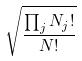<formula> <loc_0><loc_0><loc_500><loc_500>\sqrt { \frac { \prod _ { j } N _ { j } ! } { N ! } }</formula> 